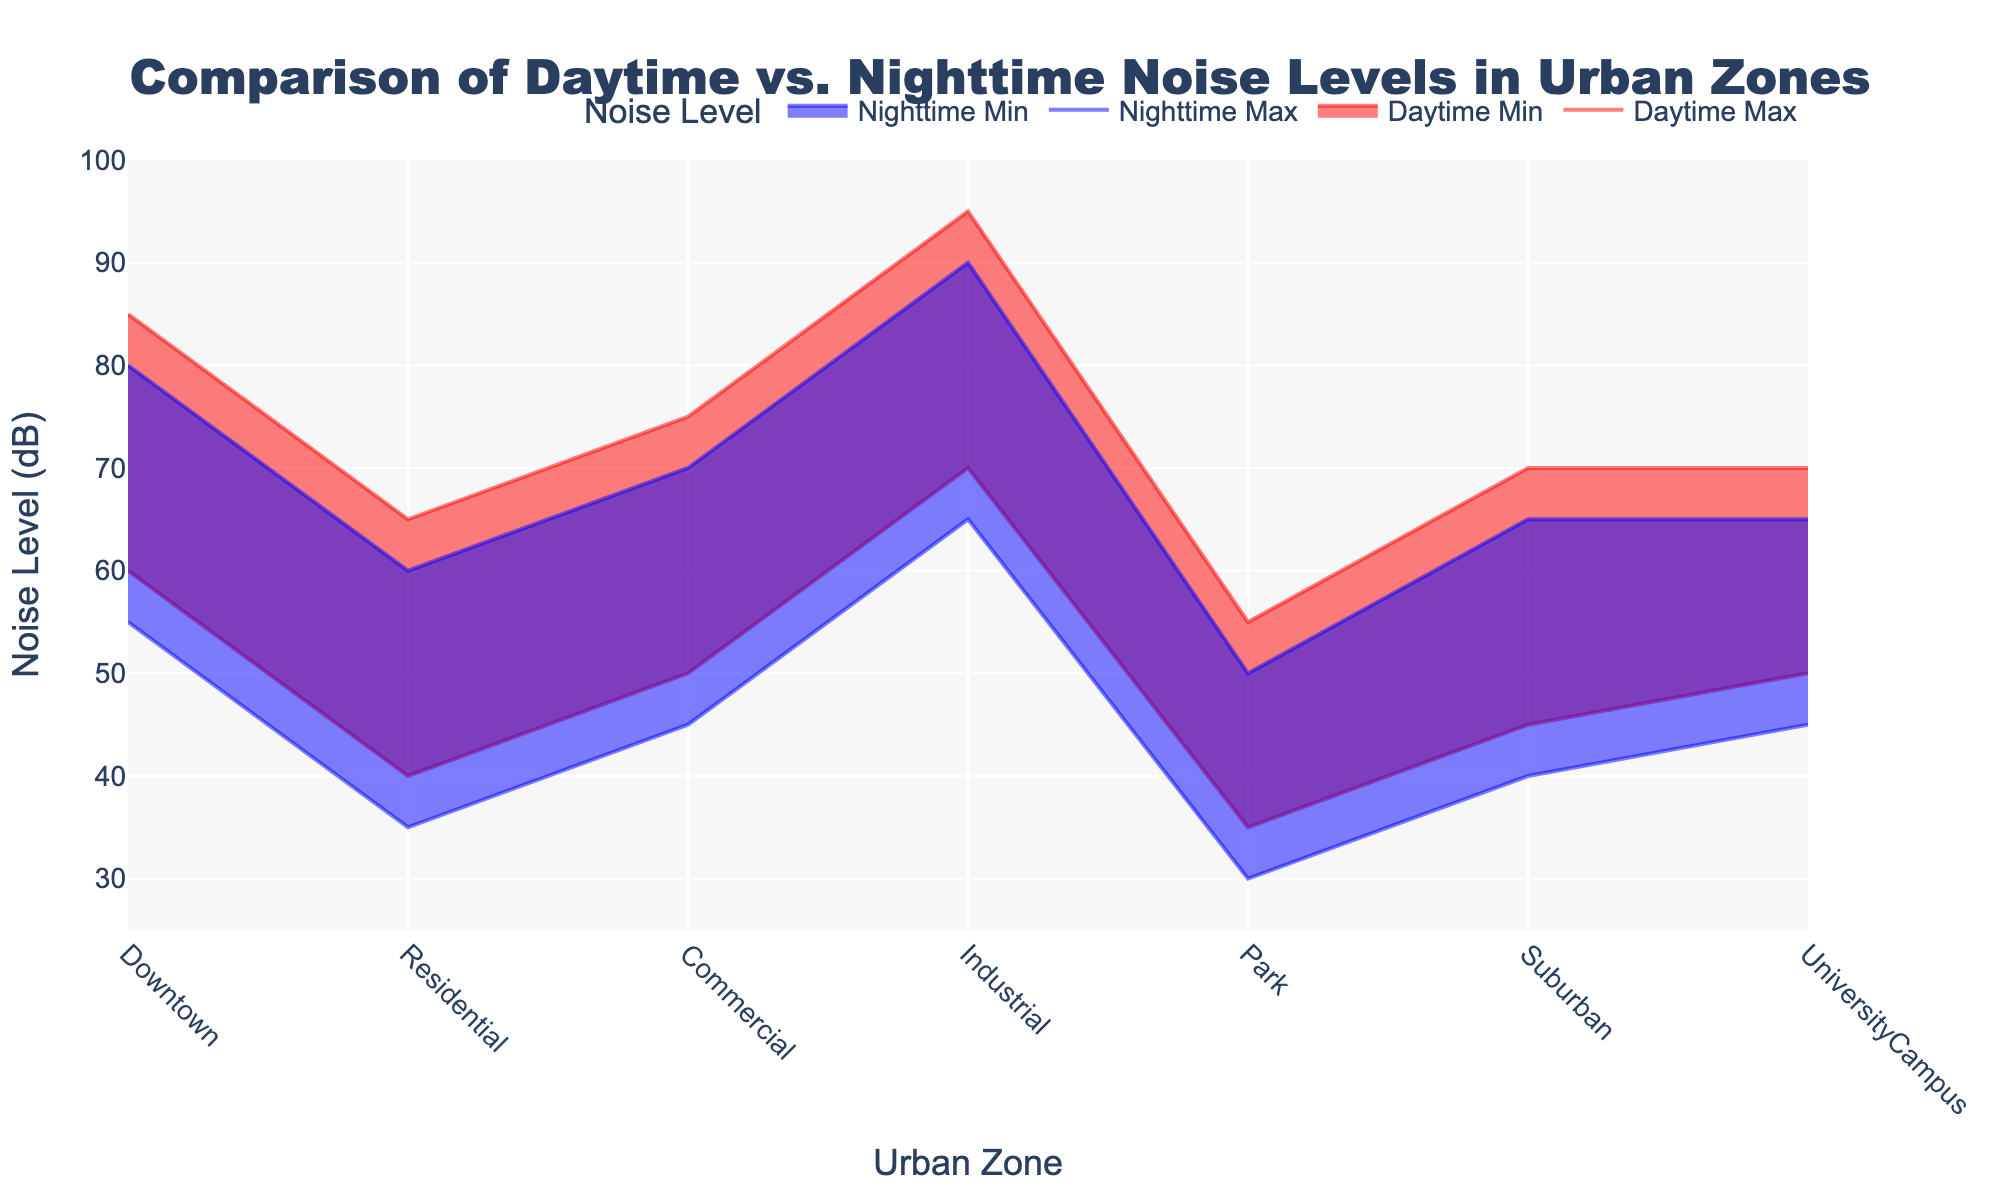What is the title of the chart? The title is typically located at the top of the chart, and it states the main topic or the data being visualized.
Answer: Comparison of Daytime vs. Nighttime Noise Levels in Urban Zones What is the noise level range in the Park zone during the daytime? The range of daytime noise levels for the Park zone can be found by looking at the minimum and maximum noise levels on the y-axis for the 'Daytime Min' and 'Daytime Max' lines.
Answer: 35-55 dB Which Urban Zone has the highest maximum nighttime noise level? To determine this, compare the maximum nighttime noise levels of all Urban Zones. The zone with the highest value in the 'Nighttime Max' line will provide the answer.
Answer: Industrial How much higher is the maximum daytime noise level in the Industrial zone compared to the Residential zone? Subtract the maximum daytime noise level of the Residential zone from that of the Industrial zone. Industrial Daytime Max (95 dB) - Residential Daytime Max (65 dB) = 30 dB.
Answer: 30 dB Which Urban Zone has the smallest difference between Daytime and Nighttime maximum noise levels? Calculate the difference between Daytime Max and Nighttime Max for each zone and identify the smallest value.
Answer: University Campus What is the average minimum noise level across all zones during nighttime? Sum the minimum nighttime noise levels of all zones and divide by the number of zones. (55+35+45+65+30+40+45) / 7 = 315 / 7 = 45 dB.
Answer: 45 dB How does the noise range in the Downtown zone during nighttime compare to the daytime? Compare the ranges of noise levels for daytime (60-85 dB) and nighttime (55-80 dB) in the Downtown zone to identify any differences or similarities.
Answer: Daytime: 25 dB, Nighttime: 25 dB In which zone is the minimum daytime noise level the highest? Check the minimum daytime noise levels for each zone and determine which has the highest value.
Answer: Industrial What is the combined noise range for the Commercial zone (both daytime and nighttime)? Calculate the range for both daytime (50-75 dB) and nighttime (45-70 dB), then check the differences.
Answer: Daytime: 25 dB, Nighttime: 25 dB 